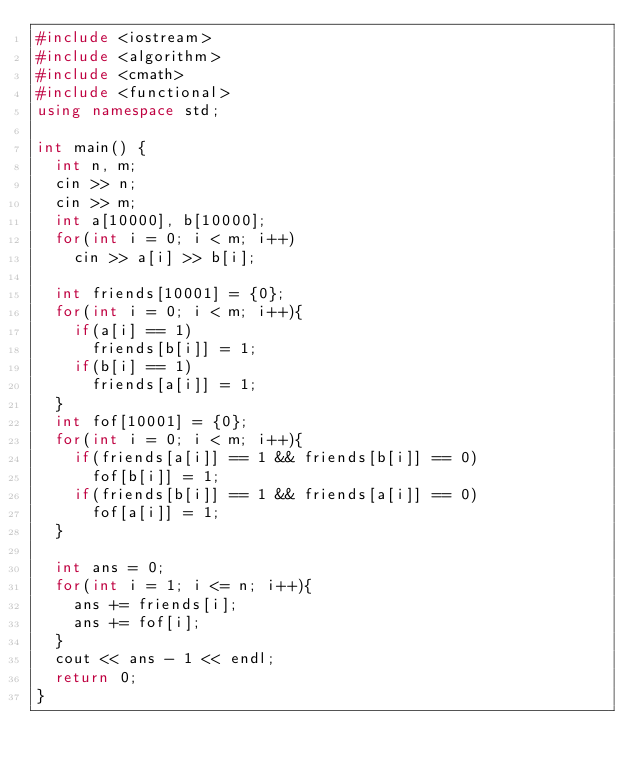Convert code to text. <code><loc_0><loc_0><loc_500><loc_500><_C++_>#include <iostream>
#include <algorithm>
#include <cmath>
#include <functional>
using namespace std;

int main() {
	int n, m;
	cin >> n;
	cin >> m;
	int a[10000], b[10000];
	for(int i = 0; i < m; i++)
		cin >> a[i] >> b[i];
		
	int friends[10001] = {0};
	for(int i = 0; i < m; i++){
		if(a[i] == 1)
			friends[b[i]] = 1;
		if(b[i] == 1)
			friends[a[i]] = 1;
	}
	int fof[10001] = {0};
	for(int i = 0; i < m; i++){
		if(friends[a[i]] == 1 && friends[b[i]] == 0)
			fof[b[i]] = 1;
		if(friends[b[i]] == 1 && friends[a[i]] == 0)
			fof[a[i]] = 1;
	}
	
	int ans = 0;
	for(int i = 1; i <= n; i++){
		ans += friends[i];
		ans += fof[i];
	}
	cout << ans - 1 << endl;
	return 0;
}</code> 